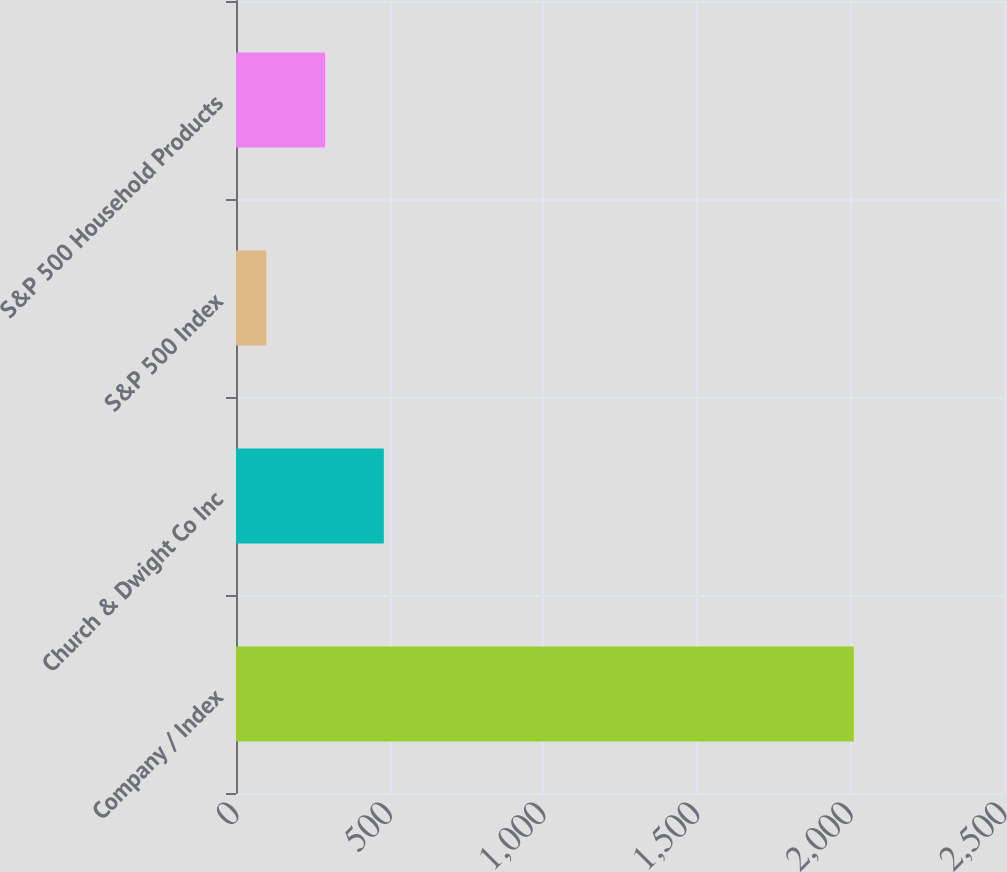Convert chart to OTSL. <chart><loc_0><loc_0><loc_500><loc_500><bar_chart><fcel>Company / Index<fcel>Church & Dwight Co Inc<fcel>S&P 500 Index<fcel>S&P 500 Household Products<nl><fcel>2011<fcel>481.2<fcel>98.76<fcel>289.98<nl></chart> 